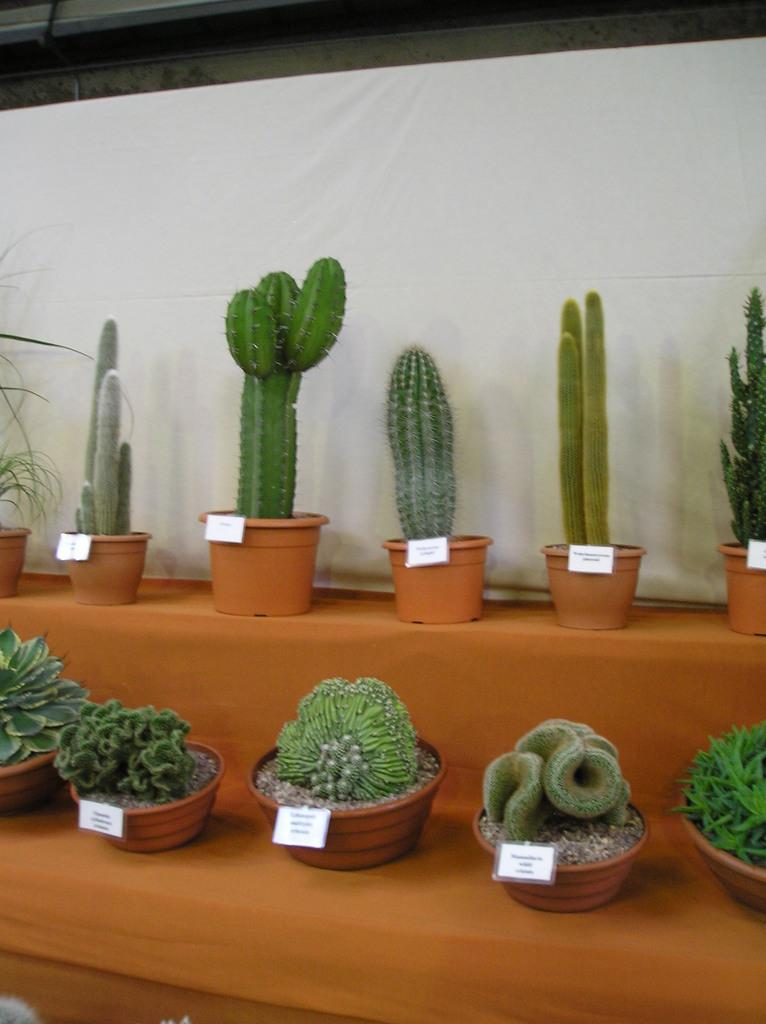What type of plants can be seen in the image? There are cactus plants and other plants in the image. How are the plants arranged in the image? The plants are in flower pots. Are there any labels or tags on the flower pots? Yes, the flower pots have tags. Where are the flower pots placed in the image? The flower pots are on tables. What can be seen in the background of the image? There is a cloth visible in the background of the image. What type of tin is being used to water the plants in the image? There is no tin visible in the image, and no indication of watering the plants. 